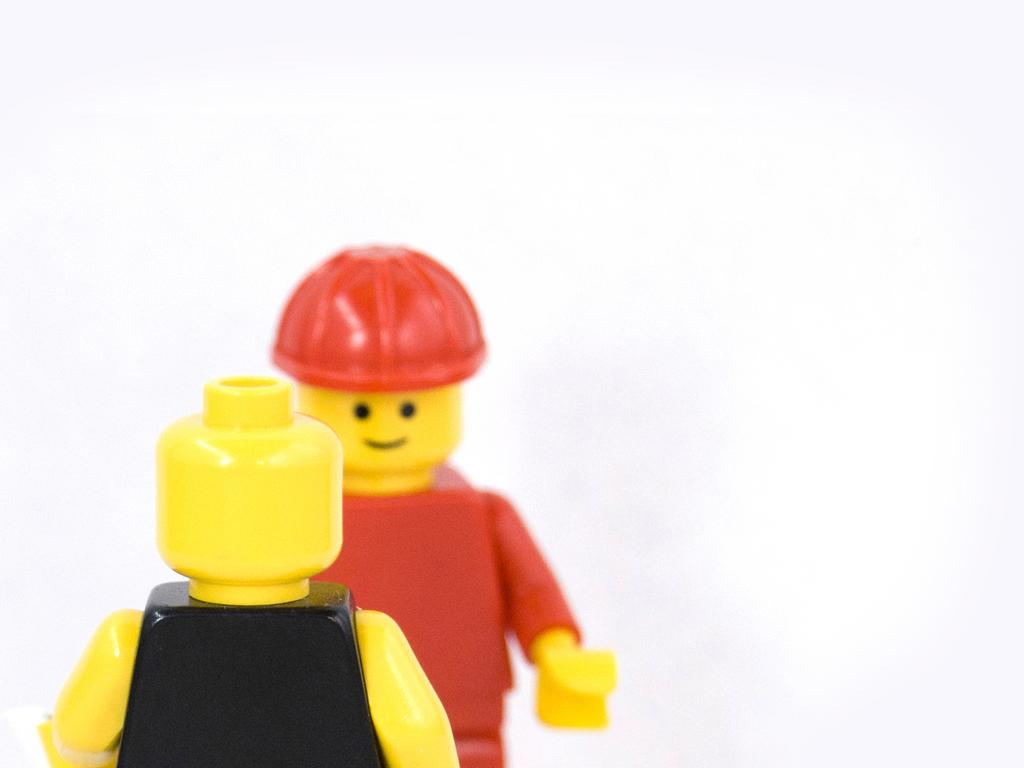What objects are present in the image? There are two toys in the image. How are the toys positioned in relation to each other? The toys are placed opposite to each other. What color is the background of the toys? The background of the toys is white. What type of note is being played by the toys in the image? There are no musical instruments or notes present in the image; it features two toys placed opposite to each other with a white background. 